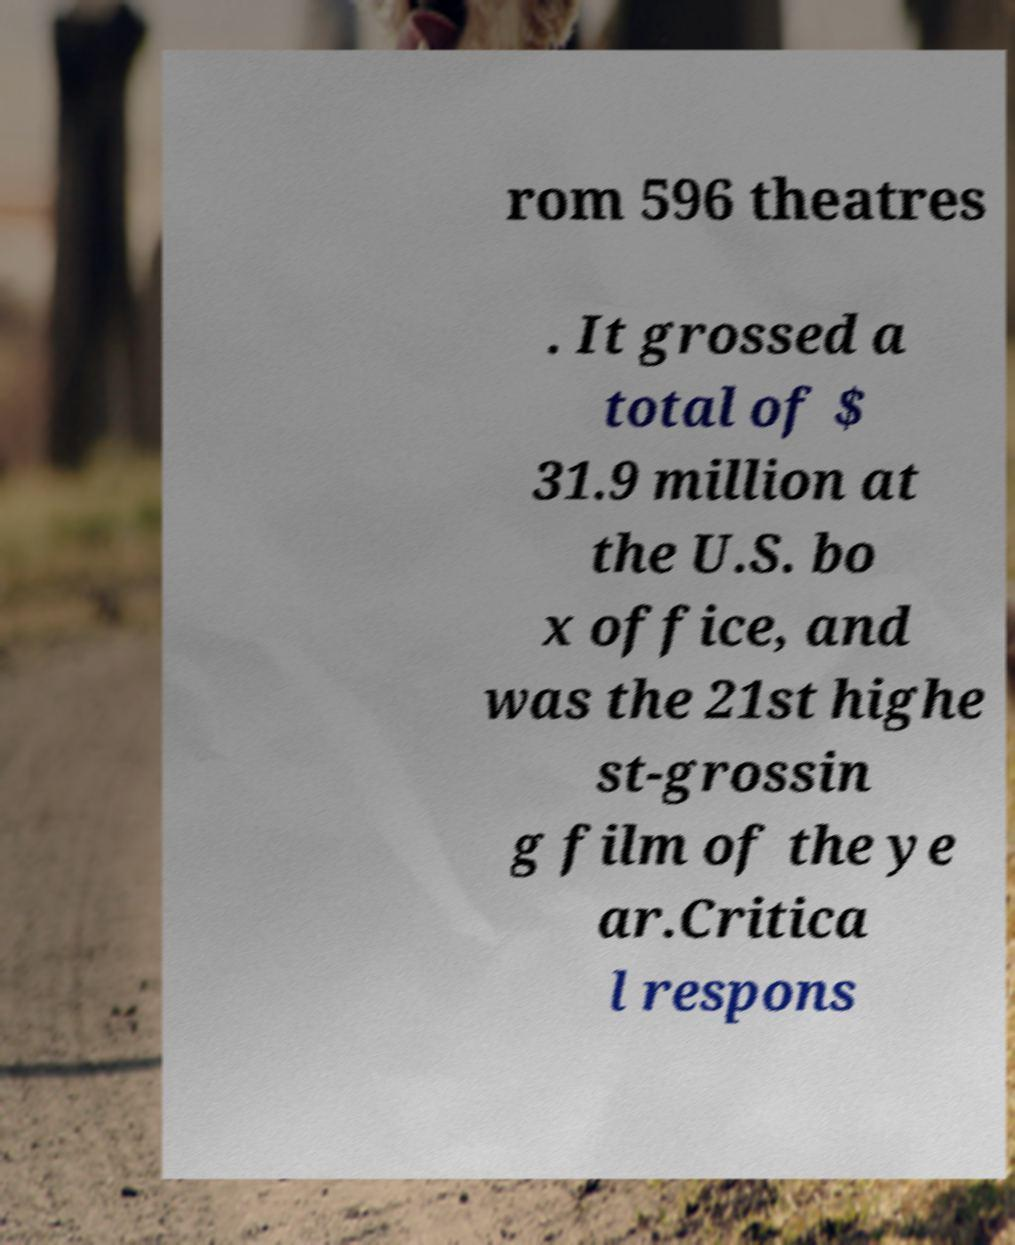What messages or text are displayed in this image? I need them in a readable, typed format. rom 596 theatres . It grossed a total of $ 31.9 million at the U.S. bo x office, and was the 21st highe st-grossin g film of the ye ar.Critica l respons 